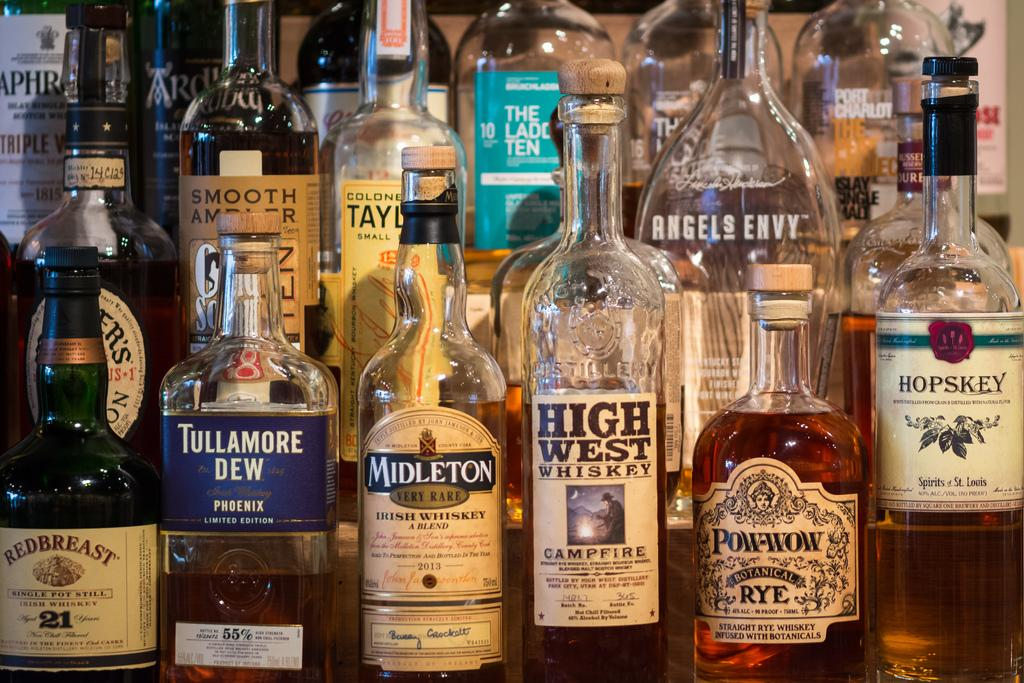<image>
Create a compact narrative representing the image presented. Different bottles of drinks which were already been opened and one of them is HIGH WEST WHISKEY. 